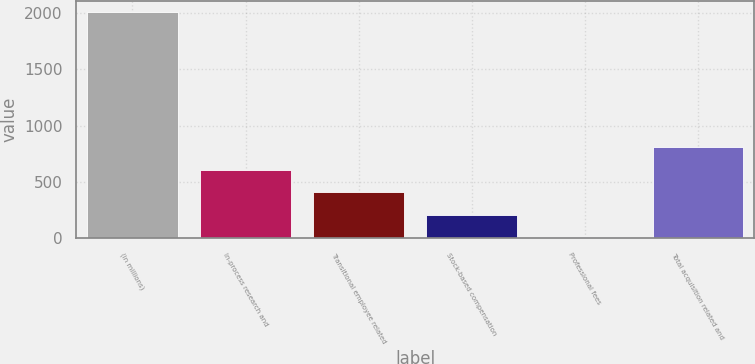Convert chart to OTSL. <chart><loc_0><loc_0><loc_500><loc_500><bar_chart><fcel>(in millions)<fcel>In-process research and<fcel>Transitional employee related<fcel>Stock-based compensation<fcel>Professional fees<fcel>Total acquisition related and<nl><fcel>2006<fcel>609.5<fcel>410<fcel>210.5<fcel>11<fcel>809<nl></chart> 